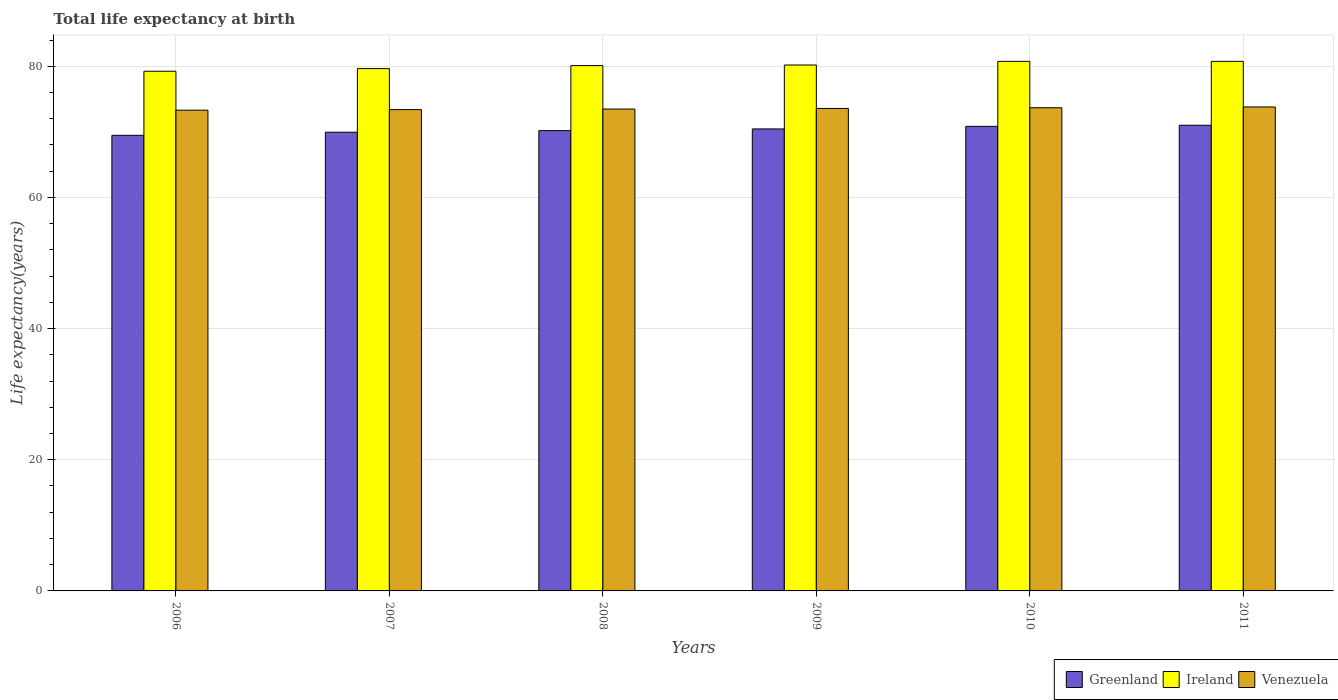How many groups of bars are there?
Keep it short and to the point. 6. Are the number of bars on each tick of the X-axis equal?
Offer a very short reply. Yes. How many bars are there on the 5th tick from the left?
Make the answer very short. 3. How many bars are there on the 1st tick from the right?
Provide a succinct answer. 3. What is the label of the 3rd group of bars from the left?
Your response must be concise. 2008. In how many cases, is the number of bars for a given year not equal to the number of legend labels?
Offer a terse response. 0. What is the life expectancy at birth in in Greenland in 2009?
Provide a short and direct response. 70.44. Across all years, what is the maximum life expectancy at birth in in Venezuela?
Keep it short and to the point. 73.79. Across all years, what is the minimum life expectancy at birth in in Greenland?
Your response must be concise. 69.47. In which year was the life expectancy at birth in in Ireland maximum?
Your answer should be compact. 2011. In which year was the life expectancy at birth in in Greenland minimum?
Keep it short and to the point. 2006. What is the total life expectancy at birth in in Greenland in the graph?
Ensure brevity in your answer.  421.88. What is the difference between the life expectancy at birth in in Ireland in 2008 and that in 2010?
Offer a very short reply. -0.65. What is the difference between the life expectancy at birth in in Ireland in 2009 and the life expectancy at birth in in Venezuela in 2006?
Your response must be concise. 6.89. What is the average life expectancy at birth in in Venezuela per year?
Offer a terse response. 73.53. In the year 2010, what is the difference between the life expectancy at birth in in Greenland and life expectancy at birth in in Venezuela?
Ensure brevity in your answer.  -2.83. What is the ratio of the life expectancy at birth in in Venezuela in 2007 to that in 2008?
Offer a terse response. 1. What is the difference between the highest and the second highest life expectancy at birth in in Greenland?
Make the answer very short. 0.16. What is the difference between the highest and the lowest life expectancy at birth in in Greenland?
Offer a very short reply. 1.53. What does the 2nd bar from the left in 2011 represents?
Your answer should be compact. Ireland. What does the 2nd bar from the right in 2009 represents?
Offer a very short reply. Ireland. Are all the bars in the graph horizontal?
Offer a very short reply. No. How many years are there in the graph?
Your answer should be very brief. 6. What is the difference between two consecutive major ticks on the Y-axis?
Your answer should be compact. 20. Are the values on the major ticks of Y-axis written in scientific E-notation?
Offer a very short reply. No. Does the graph contain any zero values?
Offer a very short reply. No. Does the graph contain grids?
Offer a very short reply. Yes. How many legend labels are there?
Your response must be concise. 3. How are the legend labels stacked?
Offer a very short reply. Horizontal. What is the title of the graph?
Keep it short and to the point. Total life expectancy at birth. Does "Sub-Saharan Africa (developing only)" appear as one of the legend labels in the graph?
Provide a short and direct response. No. What is the label or title of the X-axis?
Your response must be concise. Years. What is the label or title of the Y-axis?
Provide a succinct answer. Life expectancy(years). What is the Life expectancy(years) of Greenland in 2006?
Ensure brevity in your answer.  69.47. What is the Life expectancy(years) of Ireland in 2006?
Provide a succinct answer. 79.24. What is the Life expectancy(years) in Venezuela in 2006?
Ensure brevity in your answer.  73.3. What is the Life expectancy(years) of Greenland in 2007?
Offer a terse response. 69.94. What is the Life expectancy(years) in Ireland in 2007?
Provide a short and direct response. 79.64. What is the Life expectancy(years) in Venezuela in 2007?
Provide a succinct answer. 73.39. What is the Life expectancy(years) of Greenland in 2008?
Offer a terse response. 70.18. What is the Life expectancy(years) of Ireland in 2008?
Give a very brief answer. 80.1. What is the Life expectancy(years) in Venezuela in 2008?
Give a very brief answer. 73.48. What is the Life expectancy(years) of Greenland in 2009?
Ensure brevity in your answer.  70.44. What is the Life expectancy(years) of Ireland in 2009?
Give a very brief answer. 80.19. What is the Life expectancy(years) in Venezuela in 2009?
Your answer should be very brief. 73.57. What is the Life expectancy(years) in Greenland in 2010?
Your answer should be very brief. 70.84. What is the Life expectancy(years) in Ireland in 2010?
Offer a very short reply. 80.74. What is the Life expectancy(years) of Venezuela in 2010?
Keep it short and to the point. 73.67. What is the Life expectancy(years) in Greenland in 2011?
Provide a short and direct response. 71. What is the Life expectancy(years) of Ireland in 2011?
Your answer should be compact. 80.75. What is the Life expectancy(years) of Venezuela in 2011?
Your answer should be compact. 73.79. Across all years, what is the maximum Life expectancy(years) in Greenland?
Offer a very short reply. 71. Across all years, what is the maximum Life expectancy(years) in Ireland?
Keep it short and to the point. 80.75. Across all years, what is the maximum Life expectancy(years) of Venezuela?
Provide a short and direct response. 73.79. Across all years, what is the minimum Life expectancy(years) of Greenland?
Keep it short and to the point. 69.47. Across all years, what is the minimum Life expectancy(years) of Ireland?
Make the answer very short. 79.24. Across all years, what is the minimum Life expectancy(years) in Venezuela?
Your response must be concise. 73.3. What is the total Life expectancy(years) in Greenland in the graph?
Your answer should be compact. 421.88. What is the total Life expectancy(years) of Ireland in the graph?
Your response must be concise. 480.66. What is the total Life expectancy(years) in Venezuela in the graph?
Keep it short and to the point. 441.2. What is the difference between the Life expectancy(years) of Greenland in 2006 and that in 2007?
Your response must be concise. -0.47. What is the difference between the Life expectancy(years) of Venezuela in 2006 and that in 2007?
Offer a terse response. -0.09. What is the difference between the Life expectancy(years) in Greenland in 2006 and that in 2008?
Offer a very short reply. -0.71. What is the difference between the Life expectancy(years) in Ireland in 2006 and that in 2008?
Keep it short and to the point. -0.85. What is the difference between the Life expectancy(years) of Venezuela in 2006 and that in 2008?
Ensure brevity in your answer.  -0.18. What is the difference between the Life expectancy(years) in Greenland in 2006 and that in 2009?
Ensure brevity in your answer.  -0.97. What is the difference between the Life expectancy(years) in Ireland in 2006 and that in 2009?
Give a very brief answer. -0.95. What is the difference between the Life expectancy(years) in Venezuela in 2006 and that in 2009?
Ensure brevity in your answer.  -0.27. What is the difference between the Life expectancy(years) of Greenland in 2006 and that in 2010?
Offer a terse response. -1.37. What is the difference between the Life expectancy(years) in Ireland in 2006 and that in 2010?
Provide a succinct answer. -1.5. What is the difference between the Life expectancy(years) of Venezuela in 2006 and that in 2010?
Offer a terse response. -0.37. What is the difference between the Life expectancy(years) in Greenland in 2006 and that in 2011?
Your response must be concise. -1.53. What is the difference between the Life expectancy(years) of Ireland in 2006 and that in 2011?
Your answer should be compact. -1.5. What is the difference between the Life expectancy(years) in Venezuela in 2006 and that in 2011?
Offer a terse response. -0.49. What is the difference between the Life expectancy(years) of Greenland in 2007 and that in 2008?
Your answer should be compact. -0.24. What is the difference between the Life expectancy(years) of Ireland in 2007 and that in 2008?
Make the answer very short. -0.45. What is the difference between the Life expectancy(years) in Venezuela in 2007 and that in 2008?
Provide a short and direct response. -0.09. What is the difference between the Life expectancy(years) in Greenland in 2007 and that in 2009?
Provide a short and direct response. -0.5. What is the difference between the Life expectancy(years) in Ireland in 2007 and that in 2009?
Provide a short and direct response. -0.55. What is the difference between the Life expectancy(years) of Venezuela in 2007 and that in 2009?
Your response must be concise. -0.18. What is the difference between the Life expectancy(years) of Greenland in 2007 and that in 2010?
Provide a succinct answer. -0.89. What is the difference between the Life expectancy(years) of Ireland in 2007 and that in 2010?
Your answer should be very brief. -1.1. What is the difference between the Life expectancy(years) of Venezuela in 2007 and that in 2010?
Give a very brief answer. -0.28. What is the difference between the Life expectancy(years) in Greenland in 2007 and that in 2011?
Your answer should be very brief. -1.06. What is the difference between the Life expectancy(years) in Ireland in 2007 and that in 2011?
Offer a very short reply. -1.1. What is the difference between the Life expectancy(years) in Venezuela in 2007 and that in 2011?
Provide a succinct answer. -0.4. What is the difference between the Life expectancy(years) in Greenland in 2008 and that in 2009?
Your response must be concise. -0.26. What is the difference between the Life expectancy(years) of Ireland in 2008 and that in 2009?
Keep it short and to the point. -0.1. What is the difference between the Life expectancy(years) of Venezuela in 2008 and that in 2009?
Keep it short and to the point. -0.09. What is the difference between the Life expectancy(years) in Greenland in 2008 and that in 2010?
Your answer should be very brief. -0.65. What is the difference between the Life expectancy(years) in Ireland in 2008 and that in 2010?
Offer a very short reply. -0.65. What is the difference between the Life expectancy(years) in Venezuela in 2008 and that in 2010?
Provide a succinct answer. -0.2. What is the difference between the Life expectancy(years) of Greenland in 2008 and that in 2011?
Keep it short and to the point. -0.82. What is the difference between the Life expectancy(years) of Ireland in 2008 and that in 2011?
Provide a short and direct response. -0.65. What is the difference between the Life expectancy(years) of Venezuela in 2008 and that in 2011?
Make the answer very short. -0.32. What is the difference between the Life expectancy(years) of Greenland in 2009 and that in 2010?
Offer a terse response. -0.39. What is the difference between the Life expectancy(years) of Ireland in 2009 and that in 2010?
Offer a terse response. -0.55. What is the difference between the Life expectancy(years) of Venezuela in 2009 and that in 2010?
Offer a terse response. -0.1. What is the difference between the Life expectancy(years) in Greenland in 2009 and that in 2011?
Offer a very short reply. -0.56. What is the difference between the Life expectancy(years) of Ireland in 2009 and that in 2011?
Ensure brevity in your answer.  -0.56. What is the difference between the Life expectancy(years) in Venezuela in 2009 and that in 2011?
Provide a short and direct response. -0.22. What is the difference between the Life expectancy(years) of Greenland in 2010 and that in 2011?
Make the answer very short. -0.16. What is the difference between the Life expectancy(years) of Ireland in 2010 and that in 2011?
Offer a very short reply. -0. What is the difference between the Life expectancy(years) of Venezuela in 2010 and that in 2011?
Your answer should be very brief. -0.12. What is the difference between the Life expectancy(years) of Greenland in 2006 and the Life expectancy(years) of Ireland in 2007?
Offer a terse response. -10.17. What is the difference between the Life expectancy(years) in Greenland in 2006 and the Life expectancy(years) in Venezuela in 2007?
Your answer should be compact. -3.92. What is the difference between the Life expectancy(years) of Ireland in 2006 and the Life expectancy(years) of Venezuela in 2007?
Ensure brevity in your answer.  5.85. What is the difference between the Life expectancy(years) in Greenland in 2006 and the Life expectancy(years) in Ireland in 2008?
Your response must be concise. -10.63. What is the difference between the Life expectancy(years) in Greenland in 2006 and the Life expectancy(years) in Venezuela in 2008?
Ensure brevity in your answer.  -4.01. What is the difference between the Life expectancy(years) of Ireland in 2006 and the Life expectancy(years) of Venezuela in 2008?
Your response must be concise. 5.77. What is the difference between the Life expectancy(years) of Greenland in 2006 and the Life expectancy(years) of Ireland in 2009?
Offer a terse response. -10.72. What is the difference between the Life expectancy(years) of Greenland in 2006 and the Life expectancy(years) of Venezuela in 2009?
Your response must be concise. -4.1. What is the difference between the Life expectancy(years) of Ireland in 2006 and the Life expectancy(years) of Venezuela in 2009?
Make the answer very short. 5.67. What is the difference between the Life expectancy(years) in Greenland in 2006 and the Life expectancy(years) in Ireland in 2010?
Keep it short and to the point. -11.28. What is the difference between the Life expectancy(years) in Greenland in 2006 and the Life expectancy(years) in Venezuela in 2010?
Provide a succinct answer. -4.2. What is the difference between the Life expectancy(years) of Ireland in 2006 and the Life expectancy(years) of Venezuela in 2010?
Give a very brief answer. 5.57. What is the difference between the Life expectancy(years) in Greenland in 2006 and the Life expectancy(years) in Ireland in 2011?
Make the answer very short. -11.28. What is the difference between the Life expectancy(years) in Greenland in 2006 and the Life expectancy(years) in Venezuela in 2011?
Ensure brevity in your answer.  -4.32. What is the difference between the Life expectancy(years) of Ireland in 2006 and the Life expectancy(years) of Venezuela in 2011?
Provide a succinct answer. 5.45. What is the difference between the Life expectancy(years) in Greenland in 2007 and the Life expectancy(years) in Ireland in 2008?
Keep it short and to the point. -10.15. What is the difference between the Life expectancy(years) of Greenland in 2007 and the Life expectancy(years) of Venezuela in 2008?
Your answer should be very brief. -3.53. What is the difference between the Life expectancy(years) in Ireland in 2007 and the Life expectancy(years) in Venezuela in 2008?
Your answer should be very brief. 6.17. What is the difference between the Life expectancy(years) of Greenland in 2007 and the Life expectancy(years) of Ireland in 2009?
Your answer should be compact. -10.25. What is the difference between the Life expectancy(years) of Greenland in 2007 and the Life expectancy(years) of Venezuela in 2009?
Make the answer very short. -3.63. What is the difference between the Life expectancy(years) in Ireland in 2007 and the Life expectancy(years) in Venezuela in 2009?
Your answer should be very brief. 6.07. What is the difference between the Life expectancy(years) of Greenland in 2007 and the Life expectancy(years) of Ireland in 2010?
Your answer should be very brief. -10.8. What is the difference between the Life expectancy(years) of Greenland in 2007 and the Life expectancy(years) of Venezuela in 2010?
Provide a short and direct response. -3.73. What is the difference between the Life expectancy(years) of Ireland in 2007 and the Life expectancy(years) of Venezuela in 2010?
Ensure brevity in your answer.  5.97. What is the difference between the Life expectancy(years) in Greenland in 2007 and the Life expectancy(years) in Ireland in 2011?
Provide a short and direct response. -10.8. What is the difference between the Life expectancy(years) in Greenland in 2007 and the Life expectancy(years) in Venezuela in 2011?
Make the answer very short. -3.85. What is the difference between the Life expectancy(years) in Ireland in 2007 and the Life expectancy(years) in Venezuela in 2011?
Your response must be concise. 5.85. What is the difference between the Life expectancy(years) of Greenland in 2008 and the Life expectancy(years) of Ireland in 2009?
Give a very brief answer. -10.01. What is the difference between the Life expectancy(years) in Greenland in 2008 and the Life expectancy(years) in Venezuela in 2009?
Offer a very short reply. -3.38. What is the difference between the Life expectancy(years) of Ireland in 2008 and the Life expectancy(years) of Venezuela in 2009?
Your response must be concise. 6.53. What is the difference between the Life expectancy(years) of Greenland in 2008 and the Life expectancy(years) of Ireland in 2010?
Provide a short and direct response. -10.56. What is the difference between the Life expectancy(years) in Greenland in 2008 and the Life expectancy(years) in Venezuela in 2010?
Keep it short and to the point. -3.49. What is the difference between the Life expectancy(years) of Ireland in 2008 and the Life expectancy(years) of Venezuela in 2010?
Your answer should be compact. 6.42. What is the difference between the Life expectancy(years) in Greenland in 2008 and the Life expectancy(years) in Ireland in 2011?
Provide a succinct answer. -10.56. What is the difference between the Life expectancy(years) in Greenland in 2008 and the Life expectancy(years) in Venezuela in 2011?
Keep it short and to the point. -3.61. What is the difference between the Life expectancy(years) in Ireland in 2008 and the Life expectancy(years) in Venezuela in 2011?
Your answer should be very brief. 6.3. What is the difference between the Life expectancy(years) in Greenland in 2009 and the Life expectancy(years) in Ireland in 2010?
Your answer should be compact. -10.3. What is the difference between the Life expectancy(years) of Greenland in 2009 and the Life expectancy(years) of Venezuela in 2010?
Your response must be concise. -3.23. What is the difference between the Life expectancy(years) in Ireland in 2009 and the Life expectancy(years) in Venezuela in 2010?
Offer a very short reply. 6.52. What is the difference between the Life expectancy(years) of Greenland in 2009 and the Life expectancy(years) of Ireland in 2011?
Give a very brief answer. -10.3. What is the difference between the Life expectancy(years) in Greenland in 2009 and the Life expectancy(years) in Venezuela in 2011?
Make the answer very short. -3.35. What is the difference between the Life expectancy(years) of Ireland in 2009 and the Life expectancy(years) of Venezuela in 2011?
Provide a succinct answer. 6.4. What is the difference between the Life expectancy(years) in Greenland in 2010 and the Life expectancy(years) in Ireland in 2011?
Offer a very short reply. -9.91. What is the difference between the Life expectancy(years) of Greenland in 2010 and the Life expectancy(years) of Venezuela in 2011?
Keep it short and to the point. -2.95. What is the difference between the Life expectancy(years) in Ireland in 2010 and the Life expectancy(years) in Venezuela in 2011?
Keep it short and to the point. 6.95. What is the average Life expectancy(years) in Greenland per year?
Your answer should be compact. 70.31. What is the average Life expectancy(years) in Ireland per year?
Your answer should be very brief. 80.11. What is the average Life expectancy(years) of Venezuela per year?
Make the answer very short. 73.53. In the year 2006, what is the difference between the Life expectancy(years) of Greenland and Life expectancy(years) of Ireland?
Provide a succinct answer. -9.77. In the year 2006, what is the difference between the Life expectancy(years) in Greenland and Life expectancy(years) in Venezuela?
Provide a succinct answer. -3.83. In the year 2006, what is the difference between the Life expectancy(years) in Ireland and Life expectancy(years) in Venezuela?
Offer a very short reply. 5.94. In the year 2007, what is the difference between the Life expectancy(years) of Greenland and Life expectancy(years) of Ireland?
Keep it short and to the point. -9.7. In the year 2007, what is the difference between the Life expectancy(years) of Greenland and Life expectancy(years) of Venezuela?
Your answer should be very brief. -3.45. In the year 2007, what is the difference between the Life expectancy(years) of Ireland and Life expectancy(years) of Venezuela?
Offer a terse response. 6.25. In the year 2008, what is the difference between the Life expectancy(years) in Greenland and Life expectancy(years) in Ireland?
Your response must be concise. -9.91. In the year 2008, what is the difference between the Life expectancy(years) in Greenland and Life expectancy(years) in Venezuela?
Offer a very short reply. -3.29. In the year 2008, what is the difference between the Life expectancy(years) of Ireland and Life expectancy(years) of Venezuela?
Give a very brief answer. 6.62. In the year 2009, what is the difference between the Life expectancy(years) of Greenland and Life expectancy(years) of Ireland?
Your response must be concise. -9.75. In the year 2009, what is the difference between the Life expectancy(years) of Greenland and Life expectancy(years) of Venezuela?
Ensure brevity in your answer.  -3.13. In the year 2009, what is the difference between the Life expectancy(years) in Ireland and Life expectancy(years) in Venezuela?
Your answer should be very brief. 6.62. In the year 2010, what is the difference between the Life expectancy(years) in Greenland and Life expectancy(years) in Ireland?
Make the answer very short. -9.91. In the year 2010, what is the difference between the Life expectancy(years) of Greenland and Life expectancy(years) of Venezuela?
Your response must be concise. -2.83. In the year 2010, what is the difference between the Life expectancy(years) in Ireland and Life expectancy(years) in Venezuela?
Provide a succinct answer. 7.07. In the year 2011, what is the difference between the Life expectancy(years) in Greenland and Life expectancy(years) in Ireland?
Provide a succinct answer. -9.74. In the year 2011, what is the difference between the Life expectancy(years) in Greenland and Life expectancy(years) in Venezuela?
Offer a terse response. -2.79. In the year 2011, what is the difference between the Life expectancy(years) in Ireland and Life expectancy(years) in Venezuela?
Provide a short and direct response. 6.95. What is the ratio of the Life expectancy(years) of Ireland in 2006 to that in 2008?
Your answer should be very brief. 0.99. What is the ratio of the Life expectancy(years) in Venezuela in 2006 to that in 2008?
Offer a very short reply. 1. What is the ratio of the Life expectancy(years) in Greenland in 2006 to that in 2009?
Offer a very short reply. 0.99. What is the ratio of the Life expectancy(years) of Ireland in 2006 to that in 2009?
Your answer should be compact. 0.99. What is the ratio of the Life expectancy(years) of Venezuela in 2006 to that in 2009?
Provide a short and direct response. 1. What is the ratio of the Life expectancy(years) in Greenland in 2006 to that in 2010?
Give a very brief answer. 0.98. What is the ratio of the Life expectancy(years) in Ireland in 2006 to that in 2010?
Offer a very short reply. 0.98. What is the ratio of the Life expectancy(years) of Greenland in 2006 to that in 2011?
Give a very brief answer. 0.98. What is the ratio of the Life expectancy(years) in Ireland in 2006 to that in 2011?
Offer a very short reply. 0.98. What is the ratio of the Life expectancy(years) of Venezuela in 2006 to that in 2011?
Provide a short and direct response. 0.99. What is the ratio of the Life expectancy(years) of Ireland in 2007 to that in 2008?
Make the answer very short. 0.99. What is the ratio of the Life expectancy(years) of Greenland in 2007 to that in 2009?
Ensure brevity in your answer.  0.99. What is the ratio of the Life expectancy(years) in Ireland in 2007 to that in 2009?
Provide a succinct answer. 0.99. What is the ratio of the Life expectancy(years) in Greenland in 2007 to that in 2010?
Offer a terse response. 0.99. What is the ratio of the Life expectancy(years) in Ireland in 2007 to that in 2010?
Give a very brief answer. 0.99. What is the ratio of the Life expectancy(years) of Greenland in 2007 to that in 2011?
Ensure brevity in your answer.  0.99. What is the ratio of the Life expectancy(years) in Ireland in 2007 to that in 2011?
Your answer should be very brief. 0.99. What is the ratio of the Life expectancy(years) of Greenland in 2008 to that in 2009?
Your answer should be compact. 1. What is the ratio of the Life expectancy(years) in Ireland in 2008 to that in 2009?
Keep it short and to the point. 1. What is the ratio of the Life expectancy(years) of Venezuela in 2008 to that in 2009?
Provide a succinct answer. 1. What is the ratio of the Life expectancy(years) of Greenland in 2008 to that in 2010?
Your response must be concise. 0.99. What is the ratio of the Life expectancy(years) in Ireland in 2008 to that in 2010?
Give a very brief answer. 0.99. What is the ratio of the Life expectancy(years) of Greenland in 2008 to that in 2011?
Your answer should be very brief. 0.99. What is the ratio of the Life expectancy(years) of Ireland in 2008 to that in 2011?
Ensure brevity in your answer.  0.99. What is the ratio of the Life expectancy(years) in Greenland in 2009 to that in 2010?
Provide a succinct answer. 0.99. What is the ratio of the Life expectancy(years) in Greenland in 2009 to that in 2011?
Offer a very short reply. 0.99. What is the ratio of the Life expectancy(years) in Ireland in 2009 to that in 2011?
Your response must be concise. 0.99. What is the ratio of the Life expectancy(years) of Venezuela in 2009 to that in 2011?
Offer a very short reply. 1. What is the ratio of the Life expectancy(years) in Ireland in 2010 to that in 2011?
Keep it short and to the point. 1. What is the difference between the highest and the second highest Life expectancy(years) in Greenland?
Make the answer very short. 0.16. What is the difference between the highest and the second highest Life expectancy(years) in Ireland?
Your answer should be compact. 0. What is the difference between the highest and the second highest Life expectancy(years) in Venezuela?
Your answer should be very brief. 0.12. What is the difference between the highest and the lowest Life expectancy(years) of Greenland?
Offer a terse response. 1.53. What is the difference between the highest and the lowest Life expectancy(years) of Ireland?
Ensure brevity in your answer.  1.5. What is the difference between the highest and the lowest Life expectancy(years) in Venezuela?
Provide a succinct answer. 0.49. 